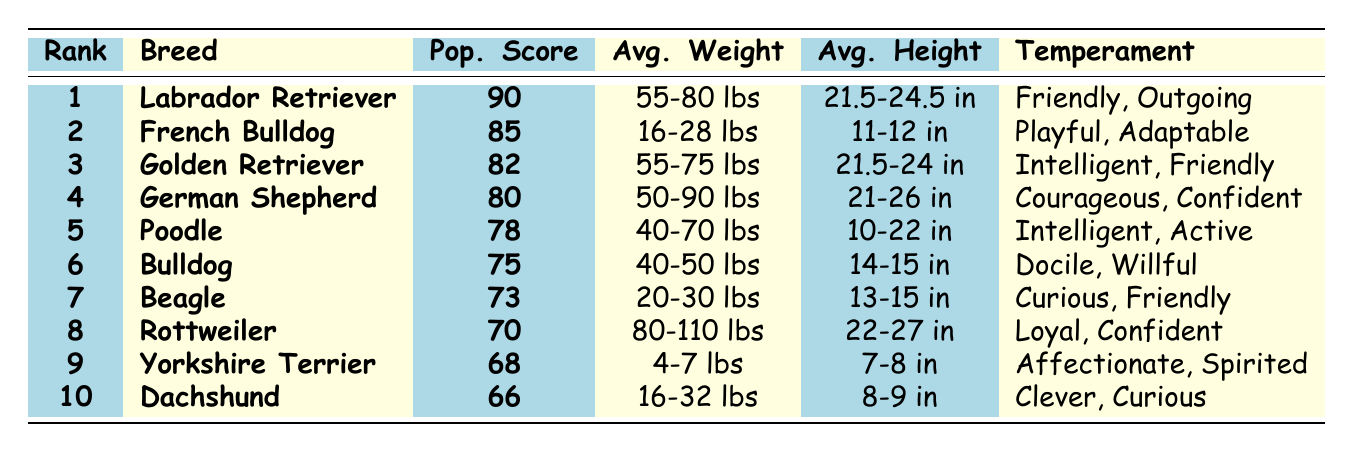What is the most popular dog breed in 2023? The table shows the rank of dog breeds, and the breed ranked 1 is "Labrador Retriever," which has the highest popularity score of 90.
Answer: Labrador Retriever Which dog breed has the second highest popularity score? According to the table, the breed with the second highest popularity score is "French Bulldog," with a score of 85.
Answer: French Bulldog What is the average weight range of a Golden Retriever? The table lists an average weight range of "55-75 lbs" for the Golden Retriever breed.
Answer: 55-75 lbs Is the Beagle's average height greater than or less than 15 inches? The table specifies that the average height for Beagles is "13-15 inches," which is less than 15 inches.
Answer: Less What is the popularity score difference between the Labrador Retriever and the Bulldog? The Labrador Retriever has a popularity score of 90, while the Bulldog has a score of 75. The difference is 90 - 75 = 15.
Answer: 15 What breed has an average height closest to 10 inches? The table reveals that the Poodle has an average height range of "10-22 inches," which includes 10 inches (the lowest value).
Answer: Poodle Which dog has the least weight variation based on the average weight range? The Yorkshire Terrier has a very narrow range of "4-7 lbs," indicating less weight variation compared to other breeds with wider ranges.
Answer: Yorkshire Terrier What average height is shared by both the Labrador Retriever and the Golden Retriever? Both breeds have an average height of "21.5-24 inches," as indicated in the table.
Answer: 21.5-24 inches If we want to know the average weight of the top three breeds, what would that be approximately? The average weight for the top three breeds is (67.5 lbs for Labrador + 22 lbs for French Bulldog + 65 lbs for Golden Retriever) / 3. This averages to around 51.17 lbs, rounding to 51 lbs.
Answer: 51 lbs Which temperament is associated with the Rottweiler? The table lists "Loyal, Confident" as the temperament associated with the Rottweiler breed.
Answer: Loyal, Confident 